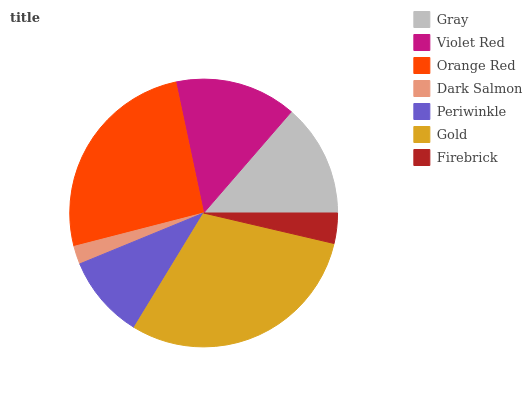Is Dark Salmon the minimum?
Answer yes or no. Yes. Is Gold the maximum?
Answer yes or no. Yes. Is Violet Red the minimum?
Answer yes or no. No. Is Violet Red the maximum?
Answer yes or no. No. Is Violet Red greater than Gray?
Answer yes or no. Yes. Is Gray less than Violet Red?
Answer yes or no. Yes. Is Gray greater than Violet Red?
Answer yes or no. No. Is Violet Red less than Gray?
Answer yes or no. No. Is Gray the high median?
Answer yes or no. Yes. Is Gray the low median?
Answer yes or no. Yes. Is Dark Salmon the high median?
Answer yes or no. No. Is Gold the low median?
Answer yes or no. No. 